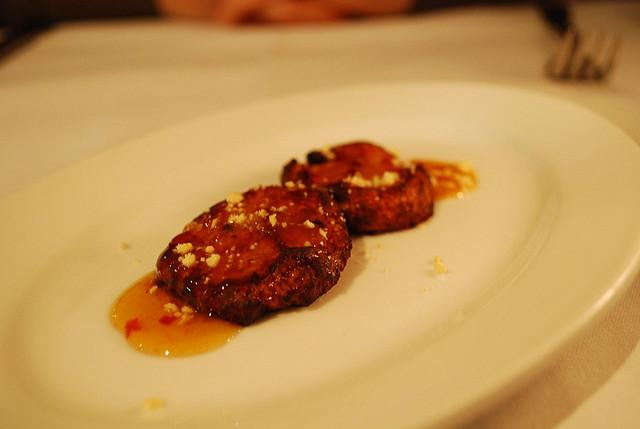What color is the plate?
Quick response, please. White. What shape is the plate?
Quick response, please. Oval. What type of food is this?
Answer briefly. Meat. How many pieces of food are on the plate?
Short answer required. 2. 